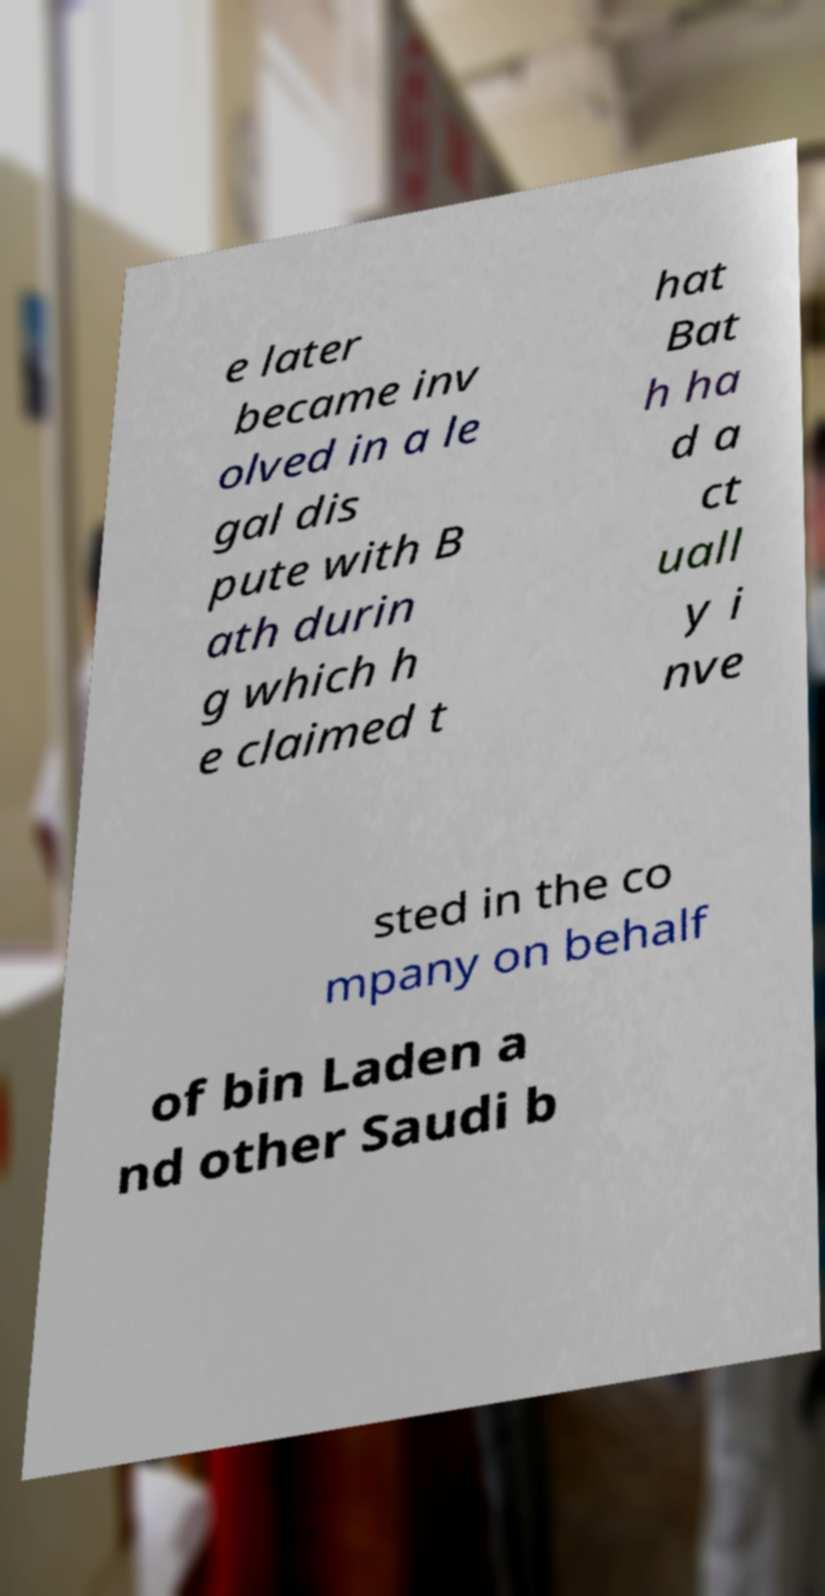Can you accurately transcribe the text from the provided image for me? e later became inv olved in a le gal dis pute with B ath durin g which h e claimed t hat Bat h ha d a ct uall y i nve sted in the co mpany on behalf of bin Laden a nd other Saudi b 